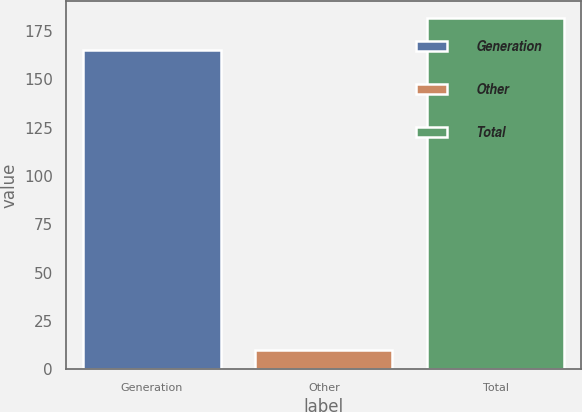<chart> <loc_0><loc_0><loc_500><loc_500><bar_chart><fcel>Generation<fcel>Other<fcel>Total<nl><fcel>165<fcel>10<fcel>181.5<nl></chart> 